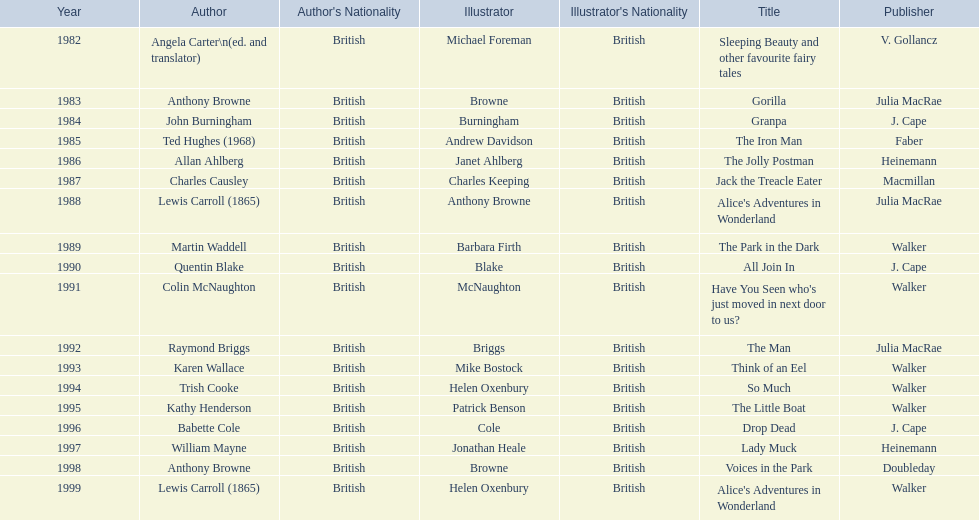Can you give me this table as a dict? {'header': ['Year', 'Author', "Author's Nationality", 'Illustrator', "Illustrator's Nationality", 'Title', 'Publisher'], 'rows': [['1982', 'Angela Carter\\n(ed. and translator)', 'British', 'Michael Foreman', 'British', 'Sleeping Beauty and other favourite fairy tales', 'V. Gollancz'], ['1983', 'Anthony Browne', 'British', 'Browne', 'British', 'Gorilla', 'Julia MacRae'], ['1984', 'John Burningham', 'British', 'Burningham', 'British', 'Granpa', 'J. Cape'], ['1985', 'Ted Hughes (1968)', 'British', 'Andrew Davidson', 'British', 'The Iron Man', 'Faber'], ['1986', 'Allan Ahlberg', 'British', 'Janet Ahlberg', 'British', 'The Jolly Postman', 'Heinemann'], ['1987', 'Charles Causley', 'British', 'Charles Keeping', 'British', 'Jack the Treacle Eater', 'Macmillan'], ['1988', 'Lewis Carroll (1865)', 'British', 'Anthony Browne', 'British', "Alice's Adventures in Wonderland", 'Julia MacRae'], ['1989', 'Martin Waddell', 'British', 'Barbara Firth', 'British', 'The Park in the Dark', 'Walker'], ['1990', 'Quentin Blake', 'British', 'Blake', 'British', 'All Join In', 'J. Cape'], ['1991', 'Colin McNaughton', 'British', 'McNaughton', 'British', "Have You Seen who's just moved in next door to us?", 'Walker'], ['1992', 'Raymond Briggs', 'British', 'Briggs', 'British', 'The Man', 'Julia MacRae'], ['1993', 'Karen Wallace', 'British', 'Mike Bostock', 'British', 'Think of an Eel', 'Walker'], ['1994', 'Trish Cooke', 'British', 'Helen Oxenbury', 'British', 'So Much', 'Walker'], ['1995', 'Kathy Henderson', 'British', 'Patrick Benson', 'British', 'The Little Boat', 'Walker'], ['1996', 'Babette Cole', 'British', 'Cole', 'British', 'Drop Dead', 'J. Cape'], ['1997', 'William Mayne', 'British', 'Jonathan Heale', 'British', 'Lady Muck', 'Heinemann'], ['1998', 'Anthony Browne', 'British', 'Browne', 'British', 'Voices in the Park', 'Doubleday'], ['1999', 'Lewis Carroll (1865)', 'British', 'Helen Oxenbury', 'British', "Alice's Adventures in Wonderland", 'Walker']]} How many number of titles are listed for the year 1991? 1. 